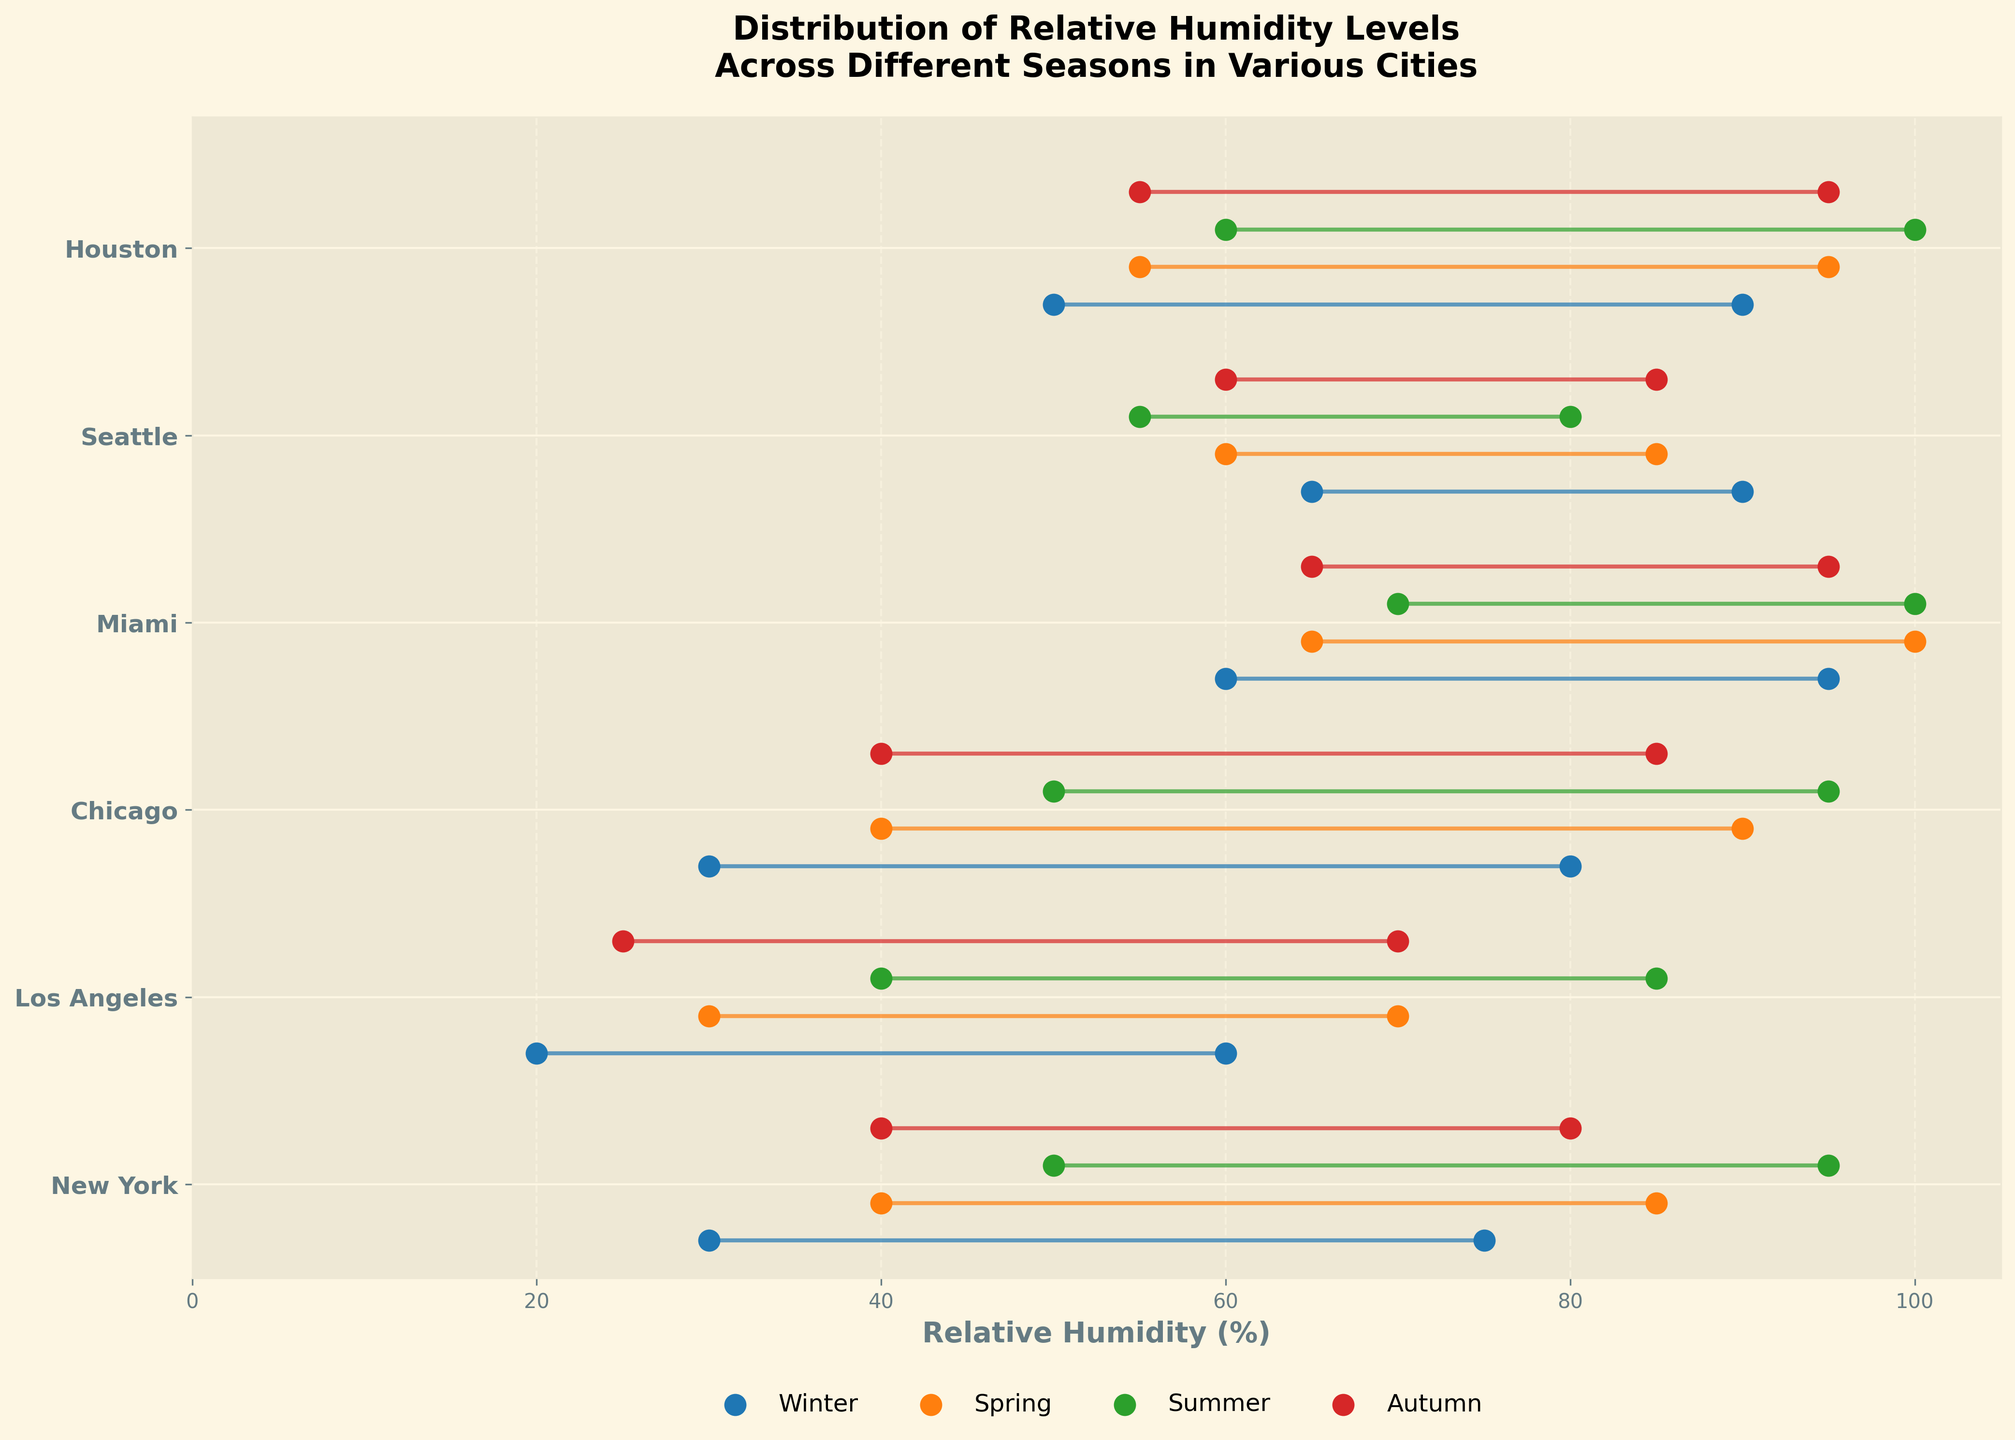What's the average minimum relative humidity for New York across all seasons? Add the minimum relative humidity of New York for all seasons: 30 (Winter) + 40 (Spring) + 50 (Summer) + 40 (Autumn) = 160. Then, divide by the number of seasons, which is 4. So, 160 / 4 = 40
Answer: 40 Which city has the largest range of relative humidity in Summer? To determine the largest range, subtract the minimum relative humidity from the maximum for each city in Summer: New York: 95 - 50 = 45, Los Angeles: 85 - 40 = 45, Chicago: 95 - 50 = 45, Miami: 100 - 70 = 30, Seattle: 80 - 55 = 25, Houston: 100 - 60 = 40. So, New York, Los Angeles, and Chicago all have a range of 45, the largest.
Answer: New York, Los Angeles, Chicago During which season does Miami have the narrowest range of relative humidity? Calculate the range for each season in Miami: Winter: 95 - 60 = 35, Spring: 100 - 65 = 35, Summer: 100 - 70 = 30, Autumn: 95 - 65 = 30. The smallest ranges are 30 for Summer and Autumn.
Answer: Summer, Autumn Does Seattle ever have a minimum or maximum relative humidity higher than Houston in any season? Compare Seattle's highs and lows to Houston's for each season: Winter: Seattle (65–90), Houston (50–90); Spring: Seattle (60–85), Houston (55–95); Summer: Seattle (55–80), Houston (60–100); Autumn: Seattle (60–85), Houston (55–95). Both the minimum and maximum values of Seattle are always less than or equal to Houston's.
Answer: No What is the title of the plot? The title of the plot is "Distribution of Relative Humidity Levels Across Different Seasons in Various Cities".
Answer: Distribution of Relative Humidity Levels Across Different Seasons in Various Cities How do the ranges of relative humidity in Winter compare between New York and Chicago? The ranges for both cities are calculated as follows: New York: 75 - 30 = 45, Chicago: 80 - 30 = 50. So, Chicago has a slightly larger range than New York in Winter.
Answer: Chicago has a larger range Which city shows the least variability in relative humidity across all seasons? To find this, calculate the range for each city in every season and compare: New York: Winter (45), Spring (45), Summer (45), Autumn (40); Los Angeles: Winter (40), Spring (40), Summer (45), Autumn (45); Chicago: Winter (50), Spring (50), Summer (45), Autumn (45); Miami: Winter (35), Spring (35), Summer (30), Autumn (30); Seattle: Winter (25), Spring (25), Summer (25), Autumn (25); Houston: Winter (40), Spring (40), Summer (40), Autumn (40). Seattle has the least variability with consistently smaller ranges.
Answer: Seattle In terms of seasons, which has the highest average maximum relative humidity across all the cities? Add the maximum relative humidity for each season across all cities: Winter: 75 (NY) + 60 (LA) + 80 (CHI) + 95 (MIA) + 90 (SEA) + 90 (HOU) = 75+60+80+95+90+90 = 490; Spring: 85 + 70 + 90 + 100 + 85 + 95 = 525; Summer: 95 + 85 + 95 + 100 + 80 + 100 = 555; Autumn: 80 + 70 + 85 + 95 + 85 + 95 = 510. Then, divide each by the number of cities (6). Winter: 490 / 6 = 81.67, Spring: 525 / 6 = 87.5, Summer: 555 / 6 = 92.5, Autumn: 510 / 6 = 85. The highest average is in Summer.
Answer: Summer Which season experiences the most consistency in relative humidity ranges across different cities? Determine the range consistency by checking the ranges for each season: Winter: [45, 40, 50, 35, 25, 40]; Spring: [45, 40, 50, 35, 25, 40]; Summer: [45, 45, 45, 30, 25, 40]; Autumn: [40, 45, 45, 30, 25, 40]. Note the spread of values. Autumn and Summer have more similar ranges overall, but Autumn ranges vary less.
Answer: Autumn 